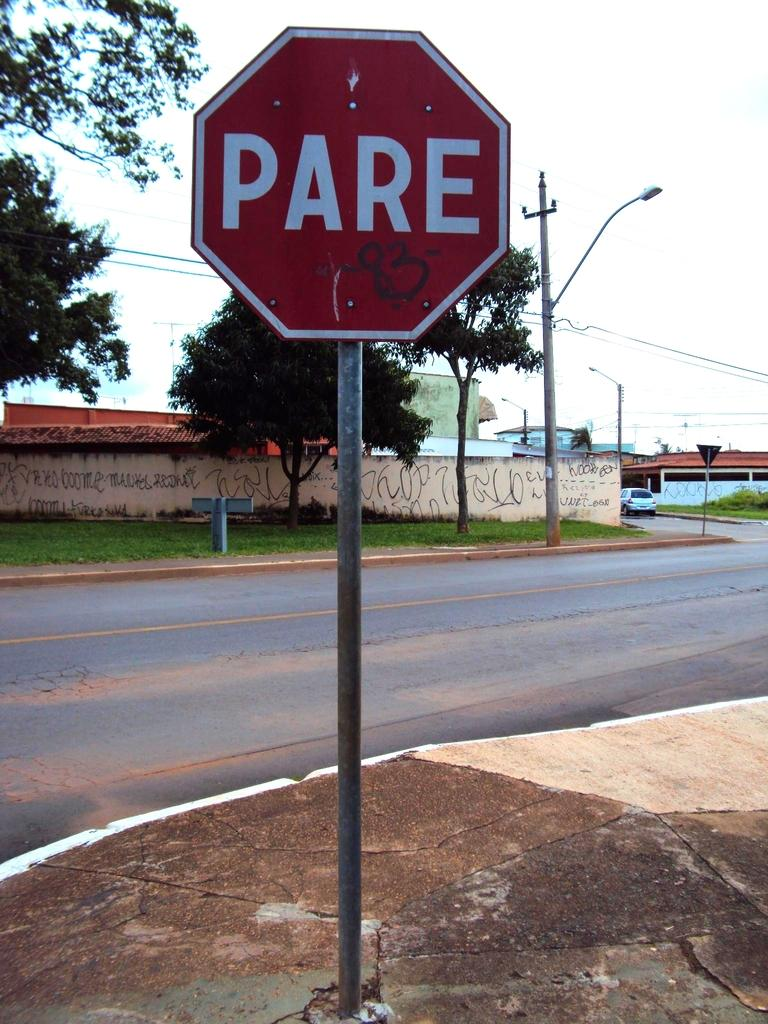<image>
Present a compact description of the photo's key features. A red street sign that says Pare on it. 